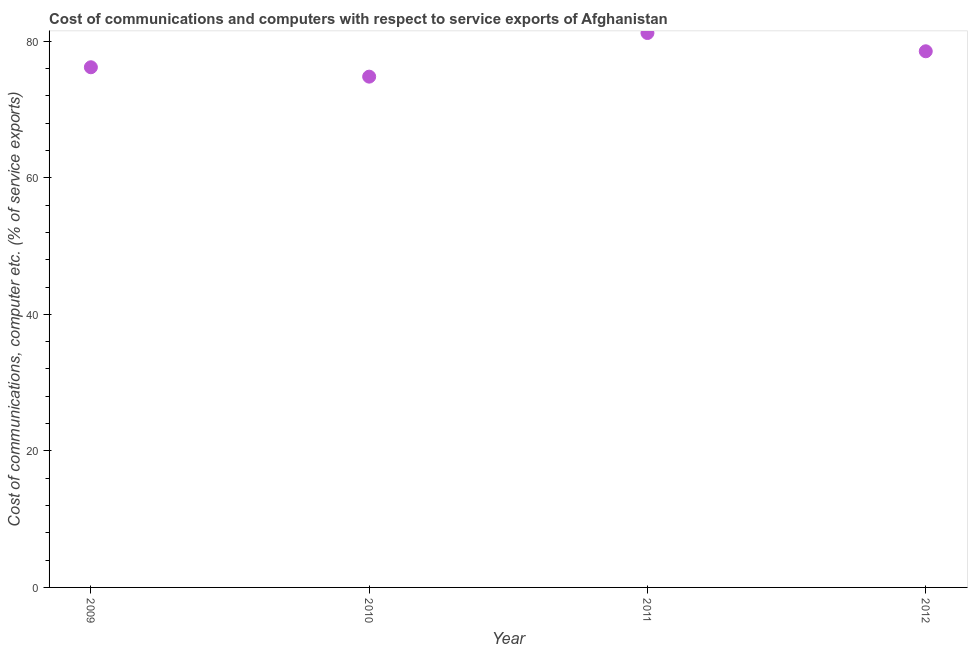What is the cost of communications and computer in 2012?
Your response must be concise. 78.52. Across all years, what is the maximum cost of communications and computer?
Your response must be concise. 81.2. Across all years, what is the minimum cost of communications and computer?
Provide a short and direct response. 74.81. In which year was the cost of communications and computer maximum?
Offer a very short reply. 2011. In which year was the cost of communications and computer minimum?
Make the answer very short. 2010. What is the sum of the cost of communications and computer?
Your answer should be very brief. 310.72. What is the difference between the cost of communications and computer in 2009 and 2010?
Offer a terse response. 1.37. What is the average cost of communications and computer per year?
Ensure brevity in your answer.  77.68. What is the median cost of communications and computer?
Your response must be concise. 77.35. Do a majority of the years between 2012 and 2011 (inclusive) have cost of communications and computer greater than 72 %?
Offer a terse response. No. What is the ratio of the cost of communications and computer in 2009 to that in 2010?
Provide a succinct answer. 1.02. Is the cost of communications and computer in 2010 less than that in 2011?
Your answer should be very brief. Yes. What is the difference between the highest and the second highest cost of communications and computer?
Give a very brief answer. 2.68. Is the sum of the cost of communications and computer in 2010 and 2011 greater than the maximum cost of communications and computer across all years?
Your answer should be very brief. Yes. What is the difference between the highest and the lowest cost of communications and computer?
Your response must be concise. 6.39. Does the cost of communications and computer monotonically increase over the years?
Your response must be concise. No. How many dotlines are there?
Keep it short and to the point. 1. What is the difference between two consecutive major ticks on the Y-axis?
Keep it short and to the point. 20. Does the graph contain grids?
Give a very brief answer. No. What is the title of the graph?
Provide a short and direct response. Cost of communications and computers with respect to service exports of Afghanistan. What is the label or title of the Y-axis?
Offer a terse response. Cost of communications, computer etc. (% of service exports). What is the Cost of communications, computer etc. (% of service exports) in 2009?
Make the answer very short. 76.18. What is the Cost of communications, computer etc. (% of service exports) in 2010?
Make the answer very short. 74.81. What is the Cost of communications, computer etc. (% of service exports) in 2011?
Make the answer very short. 81.2. What is the Cost of communications, computer etc. (% of service exports) in 2012?
Your answer should be compact. 78.52. What is the difference between the Cost of communications, computer etc. (% of service exports) in 2009 and 2010?
Provide a succinct answer. 1.37. What is the difference between the Cost of communications, computer etc. (% of service exports) in 2009 and 2011?
Provide a succinct answer. -5.02. What is the difference between the Cost of communications, computer etc. (% of service exports) in 2009 and 2012?
Your answer should be very brief. -2.34. What is the difference between the Cost of communications, computer etc. (% of service exports) in 2010 and 2011?
Your response must be concise. -6.39. What is the difference between the Cost of communications, computer etc. (% of service exports) in 2010 and 2012?
Offer a terse response. -3.72. What is the difference between the Cost of communications, computer etc. (% of service exports) in 2011 and 2012?
Provide a succinct answer. 2.68. What is the ratio of the Cost of communications, computer etc. (% of service exports) in 2009 to that in 2011?
Give a very brief answer. 0.94. What is the ratio of the Cost of communications, computer etc. (% of service exports) in 2010 to that in 2011?
Provide a succinct answer. 0.92. What is the ratio of the Cost of communications, computer etc. (% of service exports) in 2010 to that in 2012?
Keep it short and to the point. 0.95. What is the ratio of the Cost of communications, computer etc. (% of service exports) in 2011 to that in 2012?
Your answer should be compact. 1.03. 